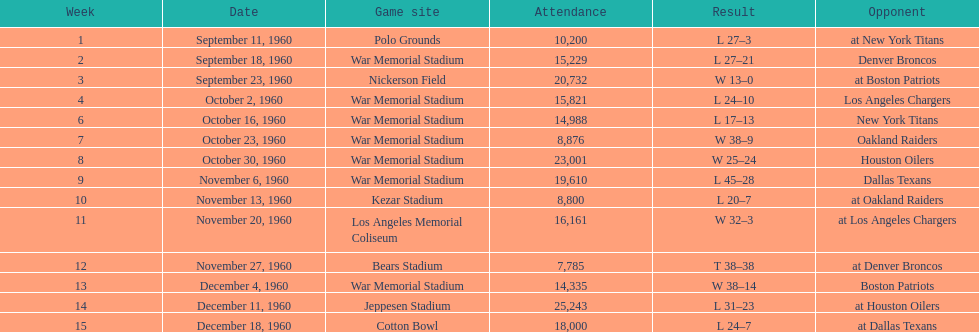What were the total number of games played in november? 4. 